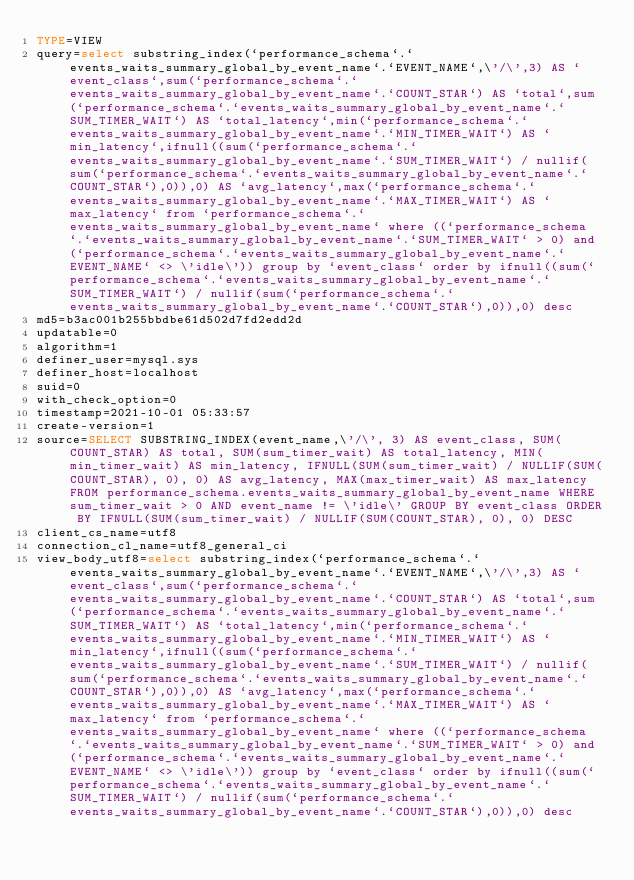Convert code to text. <code><loc_0><loc_0><loc_500><loc_500><_VisualBasic_>TYPE=VIEW
query=select substring_index(`performance_schema`.`events_waits_summary_global_by_event_name`.`EVENT_NAME`,\'/\',3) AS `event_class`,sum(`performance_schema`.`events_waits_summary_global_by_event_name`.`COUNT_STAR`) AS `total`,sum(`performance_schema`.`events_waits_summary_global_by_event_name`.`SUM_TIMER_WAIT`) AS `total_latency`,min(`performance_schema`.`events_waits_summary_global_by_event_name`.`MIN_TIMER_WAIT`) AS `min_latency`,ifnull((sum(`performance_schema`.`events_waits_summary_global_by_event_name`.`SUM_TIMER_WAIT`) / nullif(sum(`performance_schema`.`events_waits_summary_global_by_event_name`.`COUNT_STAR`),0)),0) AS `avg_latency`,max(`performance_schema`.`events_waits_summary_global_by_event_name`.`MAX_TIMER_WAIT`) AS `max_latency` from `performance_schema`.`events_waits_summary_global_by_event_name` where ((`performance_schema`.`events_waits_summary_global_by_event_name`.`SUM_TIMER_WAIT` > 0) and (`performance_schema`.`events_waits_summary_global_by_event_name`.`EVENT_NAME` <> \'idle\')) group by `event_class` order by ifnull((sum(`performance_schema`.`events_waits_summary_global_by_event_name`.`SUM_TIMER_WAIT`) / nullif(sum(`performance_schema`.`events_waits_summary_global_by_event_name`.`COUNT_STAR`),0)),0) desc
md5=b3ac001b255bbdbe61d502d7fd2edd2d
updatable=0
algorithm=1
definer_user=mysql.sys
definer_host=localhost
suid=0
with_check_option=0
timestamp=2021-10-01 05:33:57
create-version=1
source=SELECT SUBSTRING_INDEX(event_name,\'/\', 3) AS event_class, SUM(COUNT_STAR) AS total, SUM(sum_timer_wait) AS total_latency, MIN(min_timer_wait) AS min_latency, IFNULL(SUM(sum_timer_wait) / NULLIF(SUM(COUNT_STAR), 0), 0) AS avg_latency, MAX(max_timer_wait) AS max_latency FROM performance_schema.events_waits_summary_global_by_event_name WHERE sum_timer_wait > 0 AND event_name != \'idle\' GROUP BY event_class ORDER BY IFNULL(SUM(sum_timer_wait) / NULLIF(SUM(COUNT_STAR), 0), 0) DESC
client_cs_name=utf8
connection_cl_name=utf8_general_ci
view_body_utf8=select substring_index(`performance_schema`.`events_waits_summary_global_by_event_name`.`EVENT_NAME`,\'/\',3) AS `event_class`,sum(`performance_schema`.`events_waits_summary_global_by_event_name`.`COUNT_STAR`) AS `total`,sum(`performance_schema`.`events_waits_summary_global_by_event_name`.`SUM_TIMER_WAIT`) AS `total_latency`,min(`performance_schema`.`events_waits_summary_global_by_event_name`.`MIN_TIMER_WAIT`) AS `min_latency`,ifnull((sum(`performance_schema`.`events_waits_summary_global_by_event_name`.`SUM_TIMER_WAIT`) / nullif(sum(`performance_schema`.`events_waits_summary_global_by_event_name`.`COUNT_STAR`),0)),0) AS `avg_latency`,max(`performance_schema`.`events_waits_summary_global_by_event_name`.`MAX_TIMER_WAIT`) AS `max_latency` from `performance_schema`.`events_waits_summary_global_by_event_name` where ((`performance_schema`.`events_waits_summary_global_by_event_name`.`SUM_TIMER_WAIT` > 0) and (`performance_schema`.`events_waits_summary_global_by_event_name`.`EVENT_NAME` <> \'idle\')) group by `event_class` order by ifnull((sum(`performance_schema`.`events_waits_summary_global_by_event_name`.`SUM_TIMER_WAIT`) / nullif(sum(`performance_schema`.`events_waits_summary_global_by_event_name`.`COUNT_STAR`),0)),0) desc
</code> 